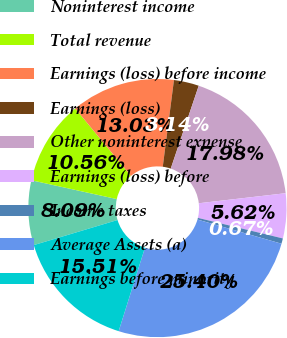Convert chart to OTSL. <chart><loc_0><loc_0><loc_500><loc_500><pie_chart><fcel>Noninterest income<fcel>Total revenue<fcel>Earnings (loss) before income<fcel>Earnings (loss)<fcel>Other noninterest expense<fcel>Earnings (loss) before<fcel>Income taxes<fcel>Average Assets (a)<fcel>Earnings before minority<nl><fcel>8.09%<fcel>10.56%<fcel>13.03%<fcel>3.14%<fcel>17.98%<fcel>5.62%<fcel>0.67%<fcel>25.4%<fcel>15.51%<nl></chart> 